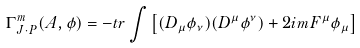<formula> <loc_0><loc_0><loc_500><loc_500>\Gamma ^ { m } _ { J \cdot P } ( A , \phi ) = - t r \int \left [ ( D _ { \mu } \phi _ { \nu } ) ( D ^ { \mu } \phi ^ { \nu } ) + 2 i m F ^ { \mu } \phi _ { \mu } \right ]</formula> 